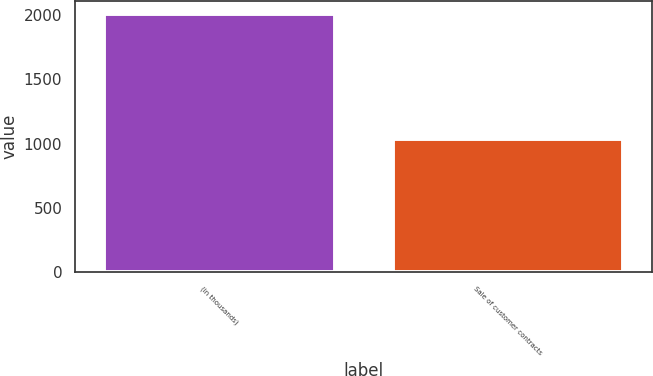Convert chart. <chart><loc_0><loc_0><loc_500><loc_500><bar_chart><fcel>(in thousands)<fcel>Sale of customer contracts<nl><fcel>2006<fcel>1036<nl></chart> 